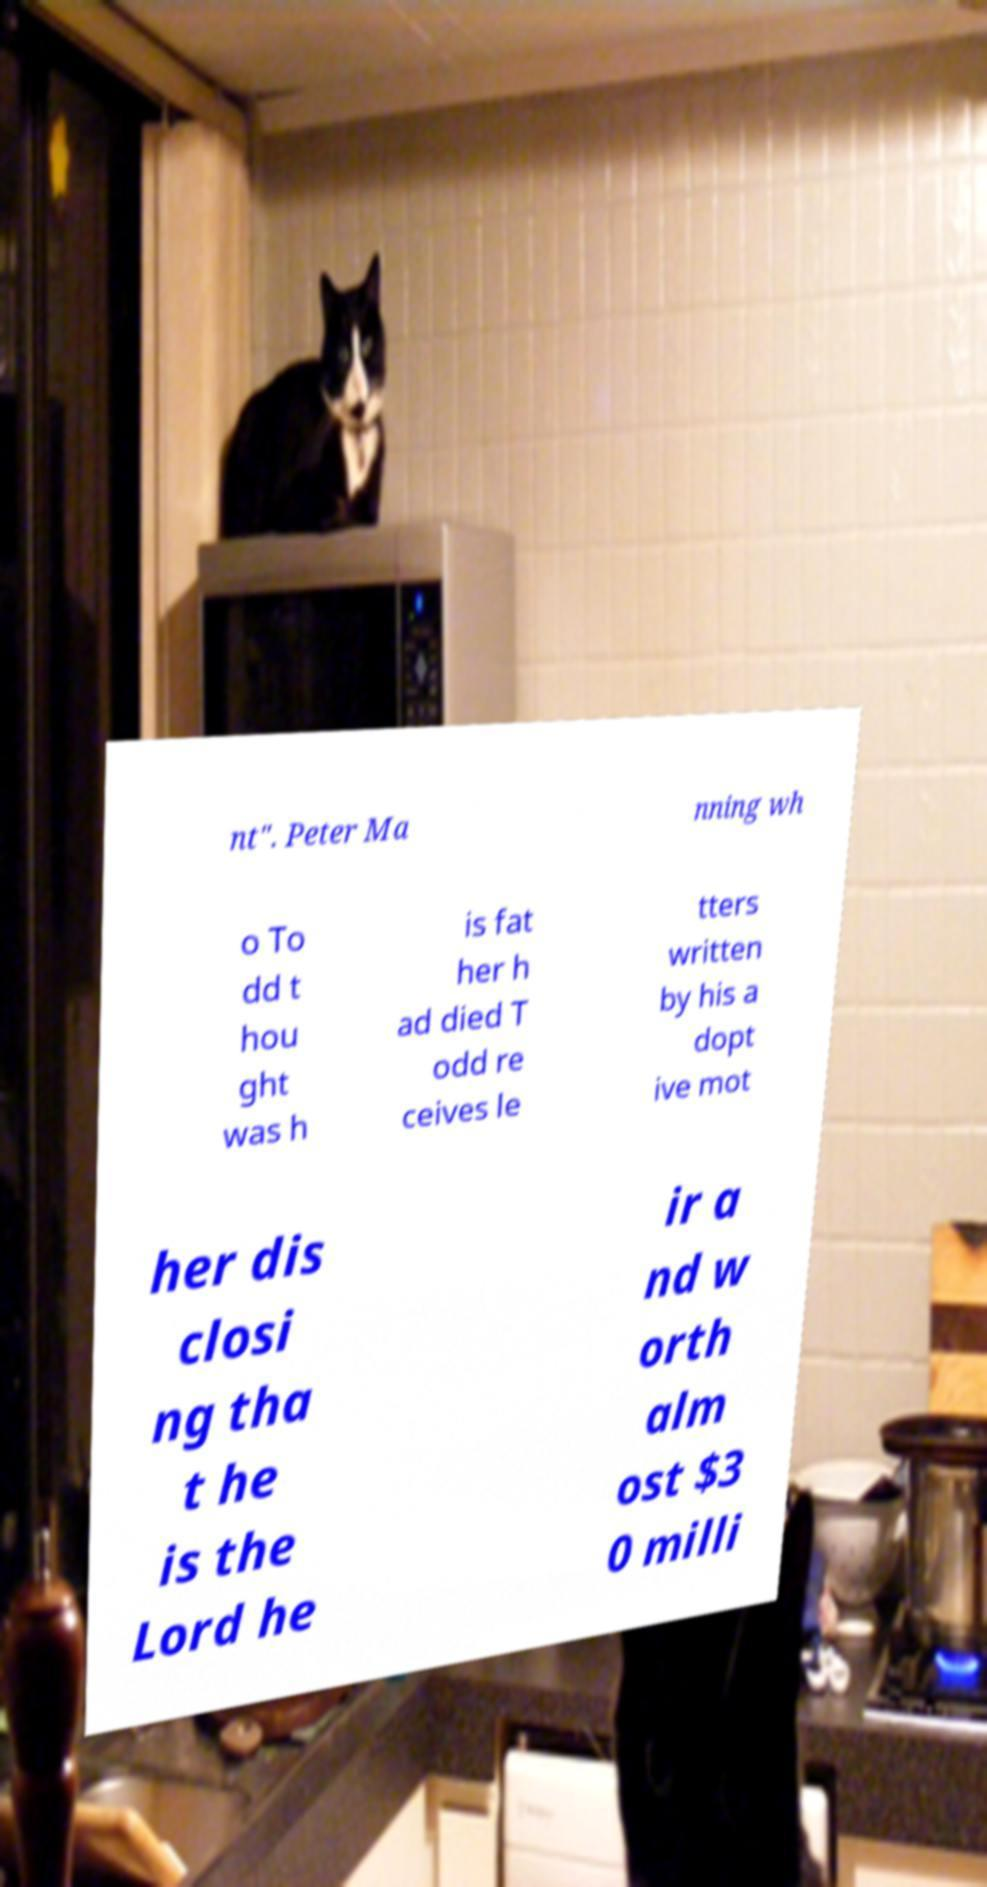What messages or text are displayed in this image? I need them in a readable, typed format. nt". Peter Ma nning wh o To dd t hou ght was h is fat her h ad died T odd re ceives le tters written by his a dopt ive mot her dis closi ng tha t he is the Lord he ir a nd w orth alm ost $3 0 milli 